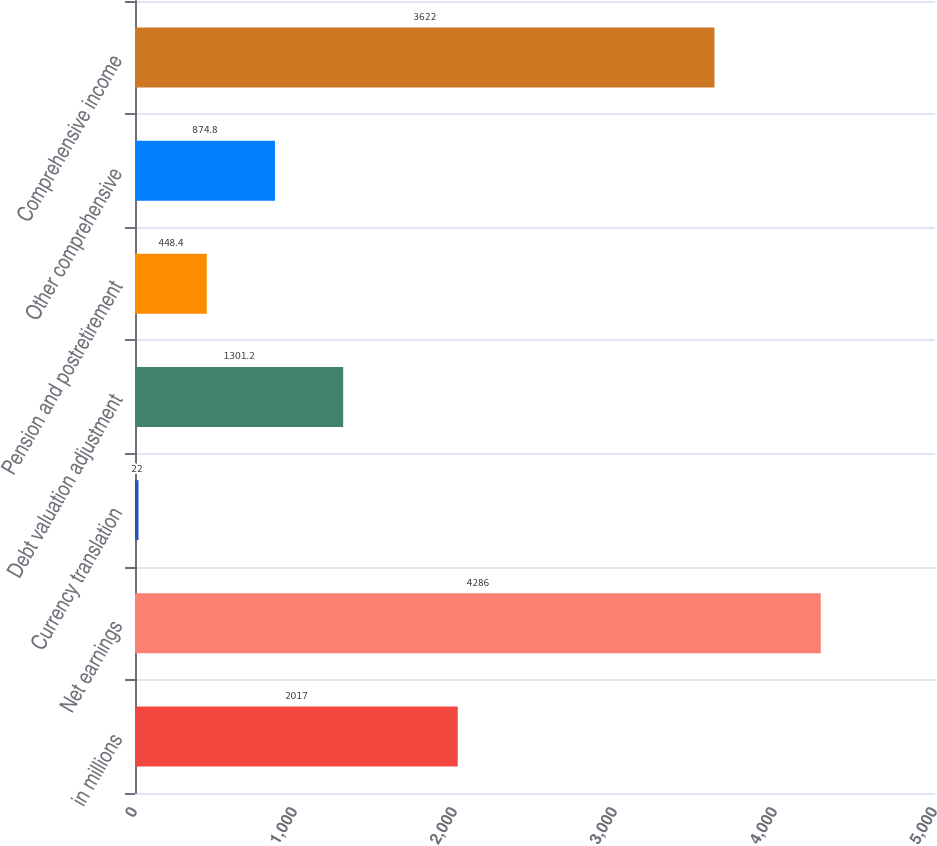Convert chart to OTSL. <chart><loc_0><loc_0><loc_500><loc_500><bar_chart><fcel>in millions<fcel>Net earnings<fcel>Currency translation<fcel>Debt valuation adjustment<fcel>Pension and postretirement<fcel>Other comprehensive<fcel>Comprehensive income<nl><fcel>2017<fcel>4286<fcel>22<fcel>1301.2<fcel>448.4<fcel>874.8<fcel>3622<nl></chart> 